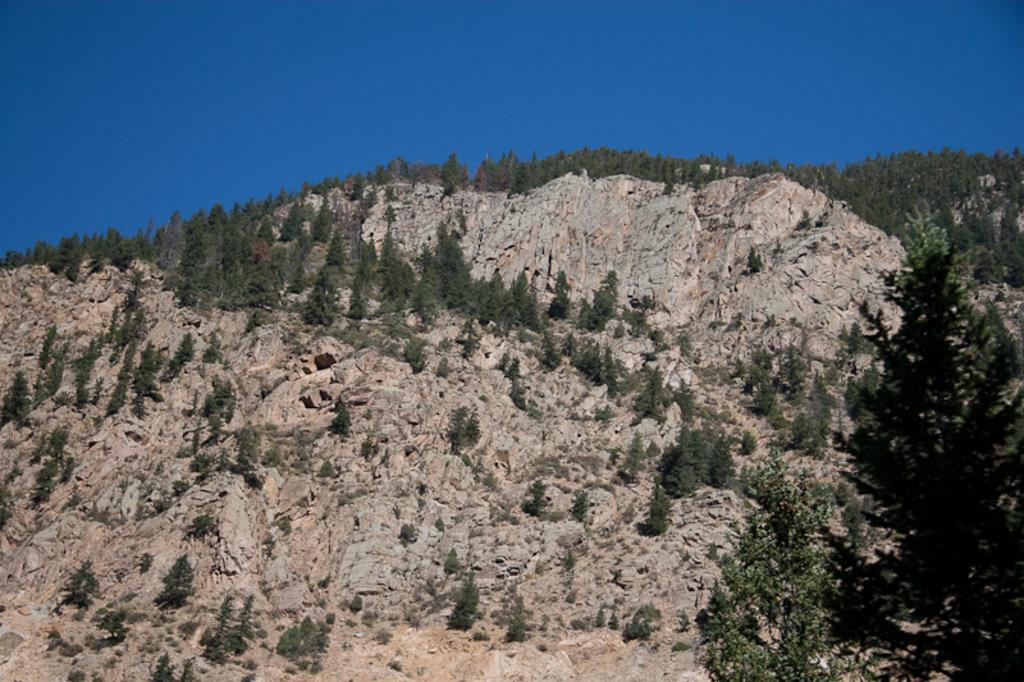What is the main feature in the center of the image? There are mountains with trees in the center of the image. What can be seen at the top of the image? The sky is visible at the top of the image. What type of collar can be seen on the pickle in the image? There is no pickle or collar present in the image. 